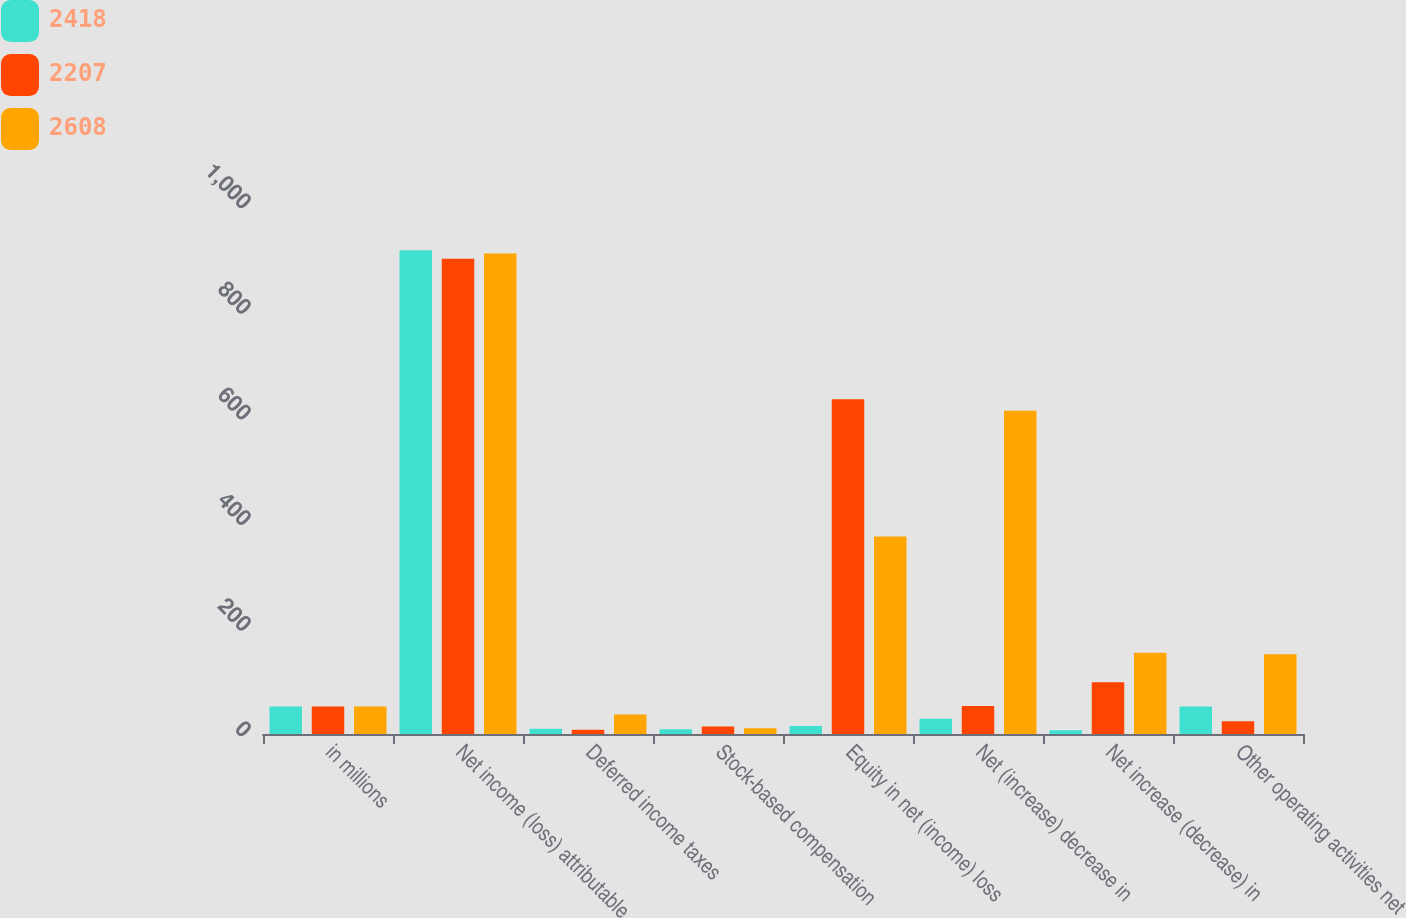<chart> <loc_0><loc_0><loc_500><loc_500><stacked_bar_chart><ecel><fcel>in millions<fcel>Net income (loss) attributable<fcel>Deferred income taxes<fcel>Stock-based compensation<fcel>Equity in net (income) loss<fcel>Net (increase) decrease in<fcel>Net increase (decrease) in<fcel>Other operating activities net<nl><fcel>2418<fcel>52<fcel>916<fcel>10<fcel>9<fcel>15<fcel>29<fcel>7<fcel>52<nl><fcel>2207<fcel>52<fcel>900<fcel>8<fcel>14<fcel>634<fcel>53<fcel>98<fcel>24<nl><fcel>2608<fcel>52<fcel>910<fcel>37<fcel>11<fcel>374<fcel>612<fcel>154<fcel>151<nl></chart> 